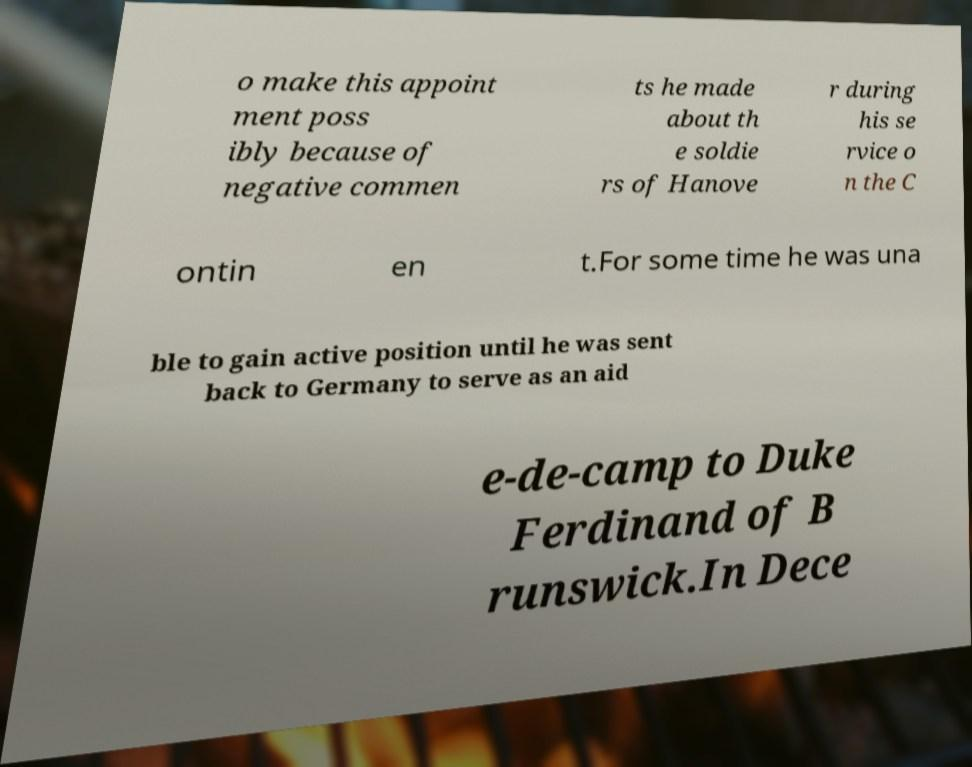Can you accurately transcribe the text from the provided image for me? o make this appoint ment poss ibly because of negative commen ts he made about th e soldie rs of Hanove r during his se rvice o n the C ontin en t.For some time he was una ble to gain active position until he was sent back to Germany to serve as an aid e-de-camp to Duke Ferdinand of B runswick.In Dece 